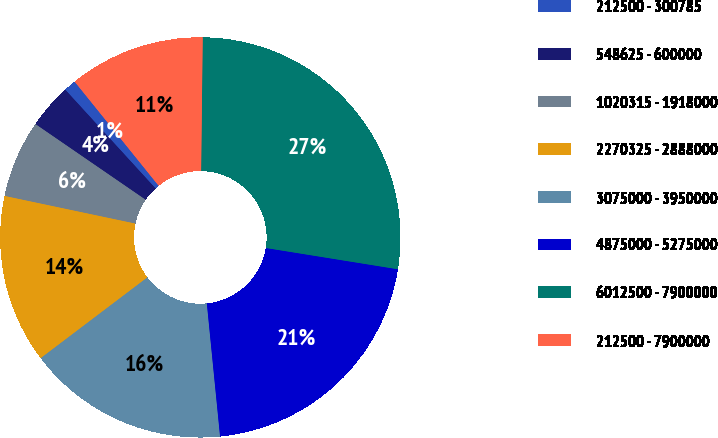Convert chart to OTSL. <chart><loc_0><loc_0><loc_500><loc_500><pie_chart><fcel>212500 - 300785<fcel>548625 - 600000<fcel>1020315 - 1918000<fcel>2270325 - 2888000<fcel>3075000 - 3950000<fcel>4875000 - 5275000<fcel>6012500 - 7900000<fcel>212500 - 7900000<nl><fcel>0.99%<fcel>3.63%<fcel>6.26%<fcel>13.63%<fcel>16.26%<fcel>20.88%<fcel>27.35%<fcel>10.99%<nl></chart> 